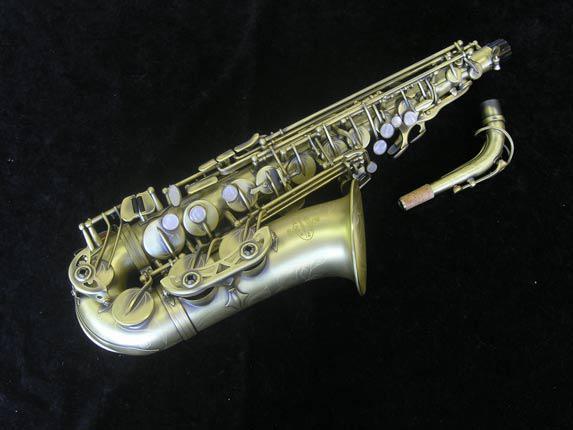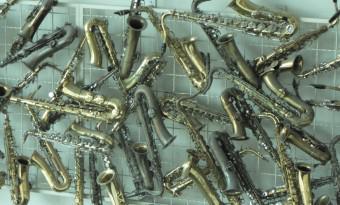The first image is the image on the left, the second image is the image on the right. Analyze the images presented: Is the assertion "There are more instruments in the image on the right." valid? Answer yes or no. Yes. The first image is the image on the left, the second image is the image on the right. Examine the images to the left and right. Is the description "An image shows one saxophone with its mouthpiece separate on the display." accurate? Answer yes or no. Yes. 